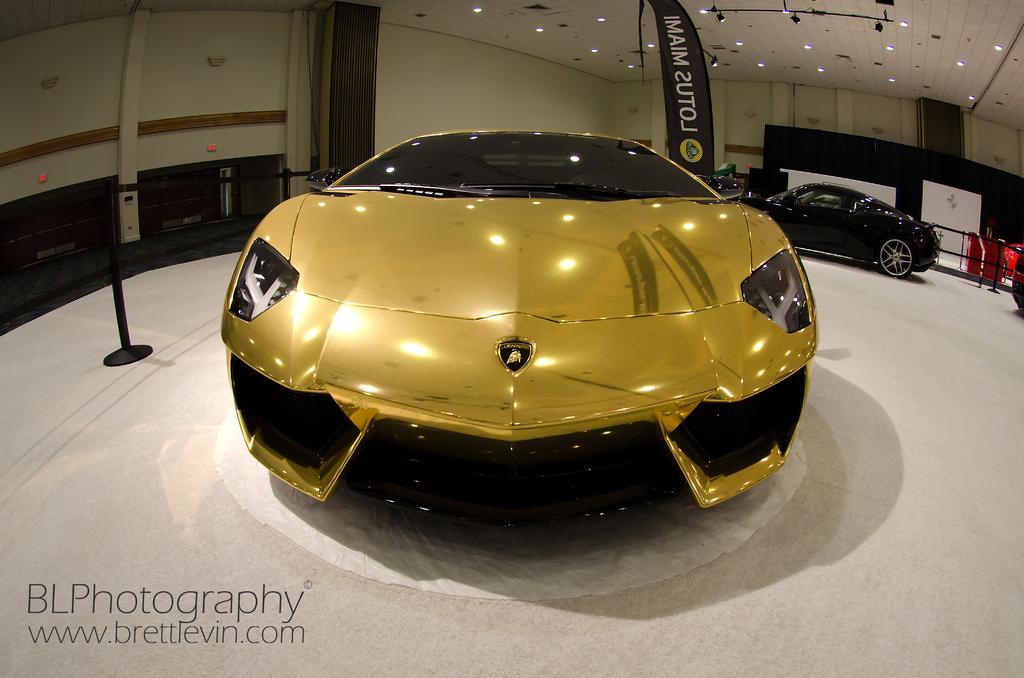Could you give a brief overview of what you see in this image? In the picture we can see a car which is gold in color and which is placed on the white color floor and beside it, we can see a pole which is black in color and behind the car we can see another car which is black in color and beside it, we can see a railing and in the background, we can see a wall and to it we can see a banner on it we can see a name lotus Miami and to the ceiling we can see the lights. 